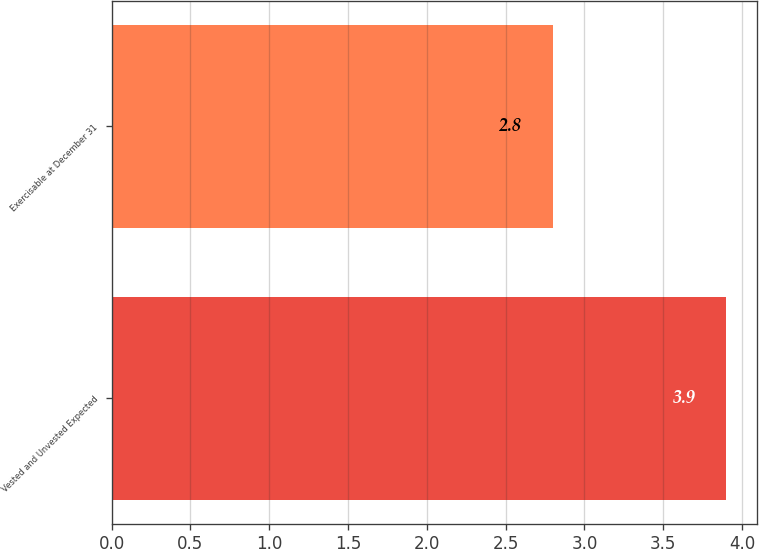Convert chart to OTSL. <chart><loc_0><loc_0><loc_500><loc_500><bar_chart><fcel>Vested and Unvested Expected<fcel>Exercisable at December 31<nl><fcel>3.9<fcel>2.8<nl></chart> 